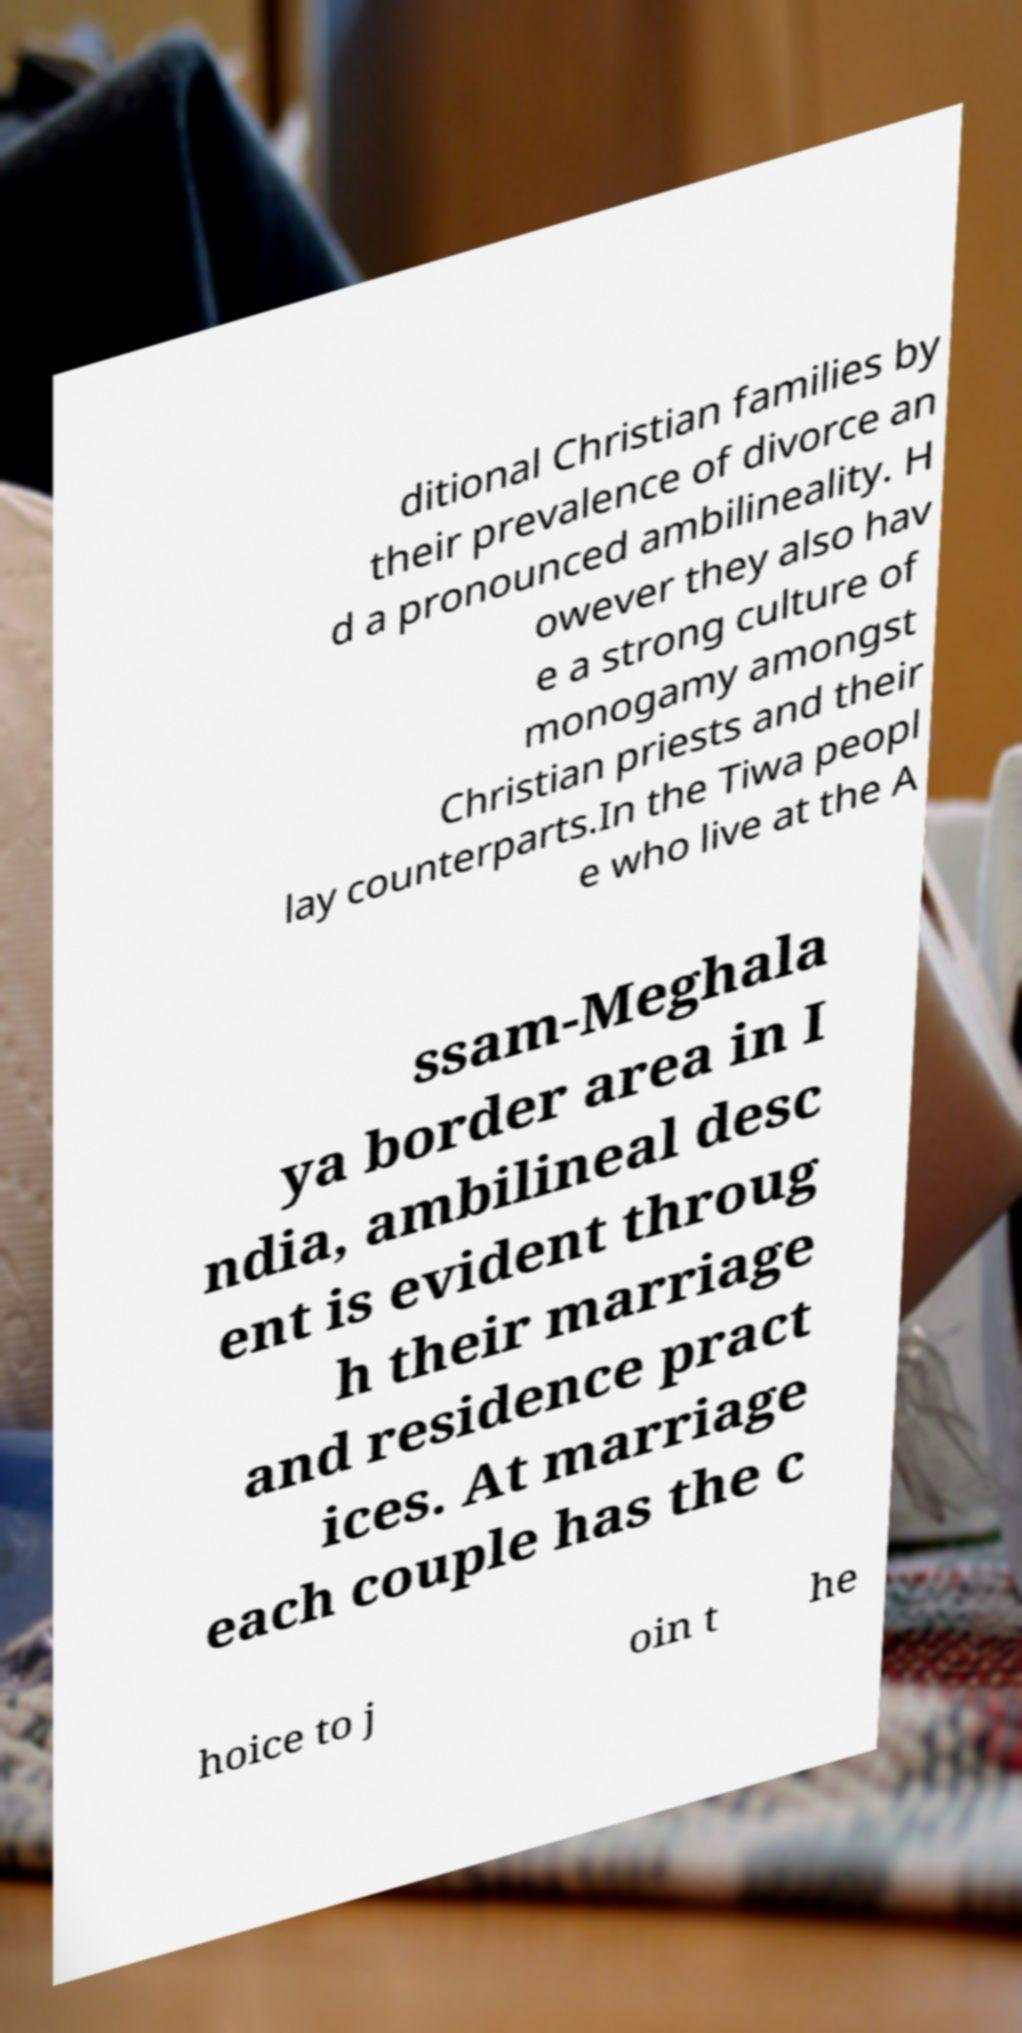Can you accurately transcribe the text from the provided image for me? ditional Christian families by their prevalence of divorce an d a pronounced ambilineality. H owever they also hav e a strong culture of monogamy amongst Christian priests and their lay counterparts.In the Tiwa peopl e who live at the A ssam-Meghala ya border area in I ndia, ambilineal desc ent is evident throug h their marriage and residence pract ices. At marriage each couple has the c hoice to j oin t he 